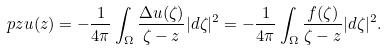<formula> <loc_0><loc_0><loc_500><loc_500>\ p { z } u ( z ) = - \frac { 1 } { 4 \pi } \int _ { \Omega } \frac { \Delta u ( \zeta ) } { \zeta - z } | d \zeta | ^ { 2 } = - \frac { 1 } { 4 \pi } \int _ { \Omega } \frac { f ( \zeta ) } { \zeta - z } | d \zeta | ^ { 2 } .</formula> 